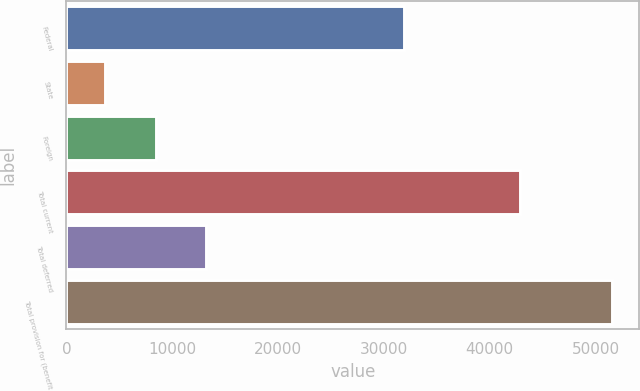Convert chart. <chart><loc_0><loc_0><loc_500><loc_500><bar_chart><fcel>Federal<fcel>State<fcel>Foreign<fcel>Total current<fcel>Total deferred<fcel>Total provision for (benefit<nl><fcel>31935<fcel>3645<fcel>8436.4<fcel>42902<fcel>13227.8<fcel>51559<nl></chart> 